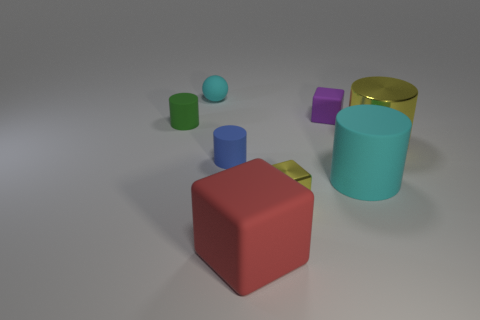Add 1 small green matte objects. How many objects exist? 9 Subtract all small cubes. How many cubes are left? 1 Subtract all yellow blocks. How many blue cylinders are left? 1 Subtract all yellow blocks. How many blocks are left? 2 Subtract all balls. How many objects are left? 7 Subtract all gray cylinders. Subtract all green balls. How many cylinders are left? 4 Subtract all small blue rubber cylinders. Subtract all red rubber things. How many objects are left? 6 Add 7 red things. How many red things are left? 8 Add 5 purple objects. How many purple objects exist? 6 Subtract 0 brown cylinders. How many objects are left? 8 